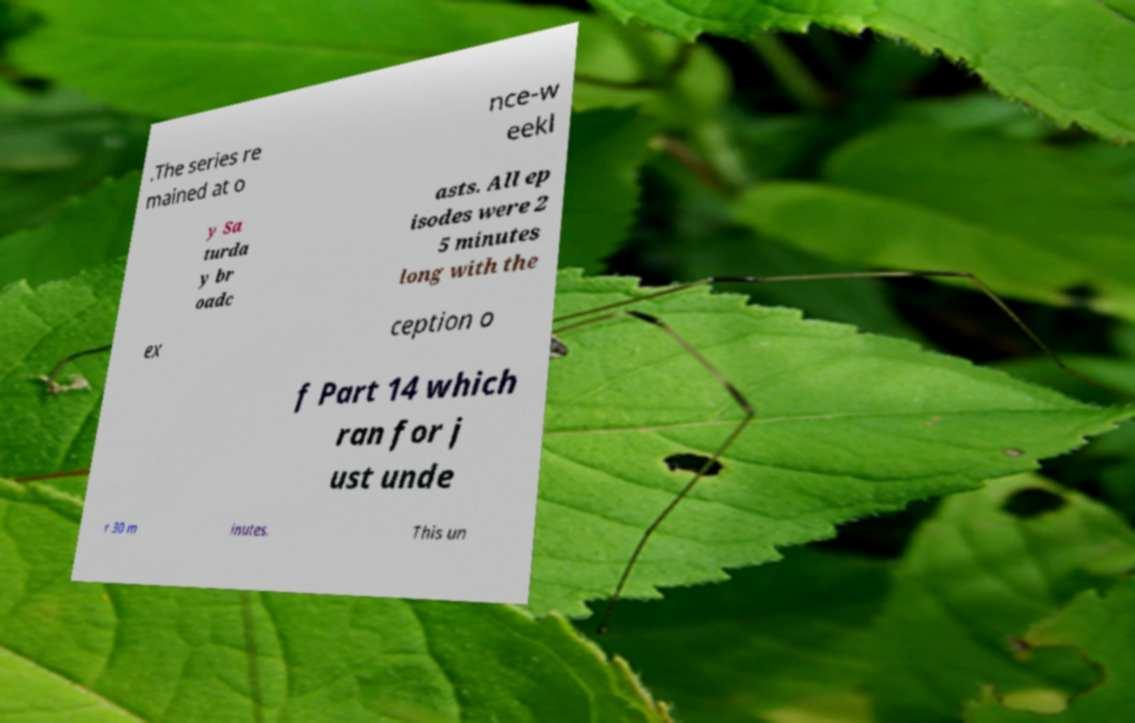Can you accurately transcribe the text from the provided image for me? .The series re mained at o nce-w eekl y Sa turda y br oadc asts. All ep isodes were 2 5 minutes long with the ex ception o f Part 14 which ran for j ust unde r 30 m inutes. This un 